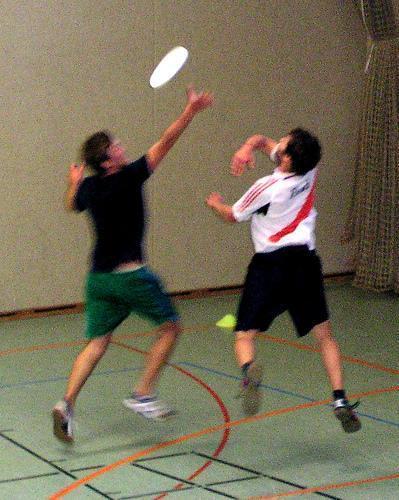How many people can you see?
Give a very brief answer. 2. How many birds are there?
Give a very brief answer. 0. 